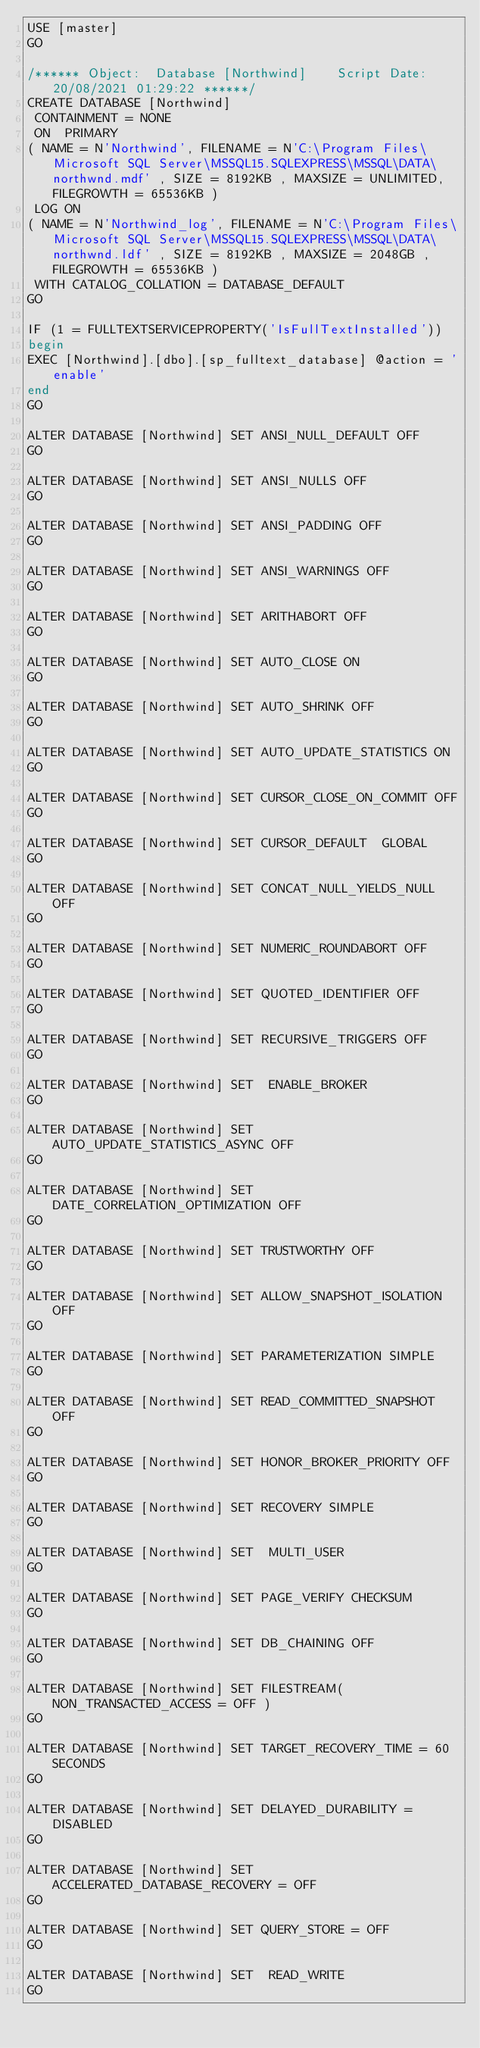<code> <loc_0><loc_0><loc_500><loc_500><_SQL_>USE [master]
GO

/****** Object:  Database [Northwind]    Script Date: 20/08/2021 01:29:22 ******/
CREATE DATABASE [Northwind]
 CONTAINMENT = NONE
 ON  PRIMARY 
( NAME = N'Northwind', FILENAME = N'C:\Program Files\Microsoft SQL Server\MSSQL15.SQLEXPRESS\MSSQL\DATA\northwnd.mdf' , SIZE = 8192KB , MAXSIZE = UNLIMITED, FILEGROWTH = 65536KB )
 LOG ON 
( NAME = N'Northwind_log', FILENAME = N'C:\Program Files\Microsoft SQL Server\MSSQL15.SQLEXPRESS\MSSQL\DATA\northwnd.ldf' , SIZE = 8192KB , MAXSIZE = 2048GB , FILEGROWTH = 65536KB )
 WITH CATALOG_COLLATION = DATABASE_DEFAULT
GO

IF (1 = FULLTEXTSERVICEPROPERTY('IsFullTextInstalled'))
begin
EXEC [Northwind].[dbo].[sp_fulltext_database] @action = 'enable'
end
GO

ALTER DATABASE [Northwind] SET ANSI_NULL_DEFAULT OFF 
GO

ALTER DATABASE [Northwind] SET ANSI_NULLS OFF 
GO

ALTER DATABASE [Northwind] SET ANSI_PADDING OFF 
GO

ALTER DATABASE [Northwind] SET ANSI_WARNINGS OFF 
GO

ALTER DATABASE [Northwind] SET ARITHABORT OFF 
GO

ALTER DATABASE [Northwind] SET AUTO_CLOSE ON 
GO

ALTER DATABASE [Northwind] SET AUTO_SHRINK OFF 
GO

ALTER DATABASE [Northwind] SET AUTO_UPDATE_STATISTICS ON 
GO

ALTER DATABASE [Northwind] SET CURSOR_CLOSE_ON_COMMIT OFF 
GO

ALTER DATABASE [Northwind] SET CURSOR_DEFAULT  GLOBAL 
GO

ALTER DATABASE [Northwind] SET CONCAT_NULL_YIELDS_NULL OFF 
GO

ALTER DATABASE [Northwind] SET NUMERIC_ROUNDABORT OFF 
GO

ALTER DATABASE [Northwind] SET QUOTED_IDENTIFIER OFF 
GO

ALTER DATABASE [Northwind] SET RECURSIVE_TRIGGERS OFF 
GO

ALTER DATABASE [Northwind] SET  ENABLE_BROKER 
GO

ALTER DATABASE [Northwind] SET AUTO_UPDATE_STATISTICS_ASYNC OFF 
GO

ALTER DATABASE [Northwind] SET DATE_CORRELATION_OPTIMIZATION OFF 
GO

ALTER DATABASE [Northwind] SET TRUSTWORTHY OFF 
GO

ALTER DATABASE [Northwind] SET ALLOW_SNAPSHOT_ISOLATION OFF 
GO

ALTER DATABASE [Northwind] SET PARAMETERIZATION SIMPLE 
GO

ALTER DATABASE [Northwind] SET READ_COMMITTED_SNAPSHOT OFF 
GO

ALTER DATABASE [Northwind] SET HONOR_BROKER_PRIORITY OFF 
GO

ALTER DATABASE [Northwind] SET RECOVERY SIMPLE 
GO

ALTER DATABASE [Northwind] SET  MULTI_USER 
GO

ALTER DATABASE [Northwind] SET PAGE_VERIFY CHECKSUM  
GO

ALTER DATABASE [Northwind] SET DB_CHAINING OFF 
GO

ALTER DATABASE [Northwind] SET FILESTREAM( NON_TRANSACTED_ACCESS = OFF ) 
GO

ALTER DATABASE [Northwind] SET TARGET_RECOVERY_TIME = 60 SECONDS 
GO

ALTER DATABASE [Northwind] SET DELAYED_DURABILITY = DISABLED 
GO

ALTER DATABASE [Northwind] SET ACCELERATED_DATABASE_RECOVERY = OFF  
GO

ALTER DATABASE [Northwind] SET QUERY_STORE = OFF
GO

ALTER DATABASE [Northwind] SET  READ_WRITE 
GO

</code> 